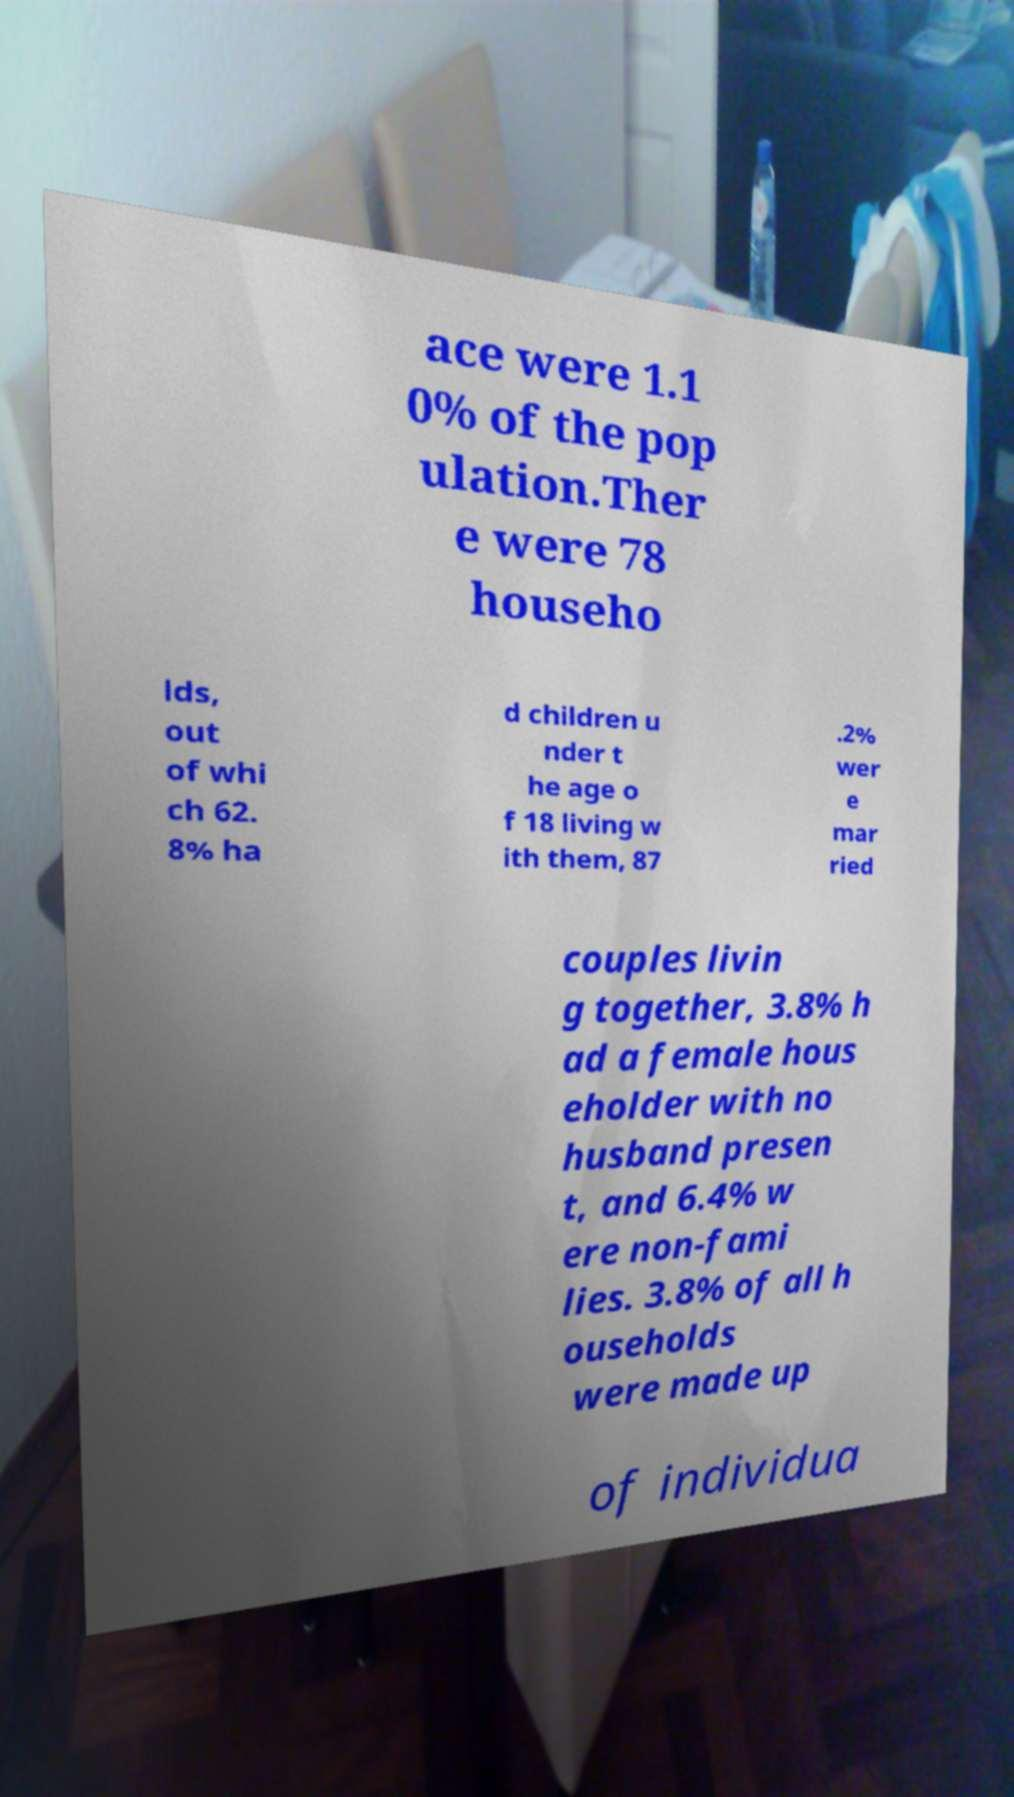Please read and relay the text visible in this image. What does it say? ace were 1.1 0% of the pop ulation.Ther e were 78 househo lds, out of whi ch 62. 8% ha d children u nder t he age o f 18 living w ith them, 87 .2% wer e mar ried couples livin g together, 3.8% h ad a female hous eholder with no husband presen t, and 6.4% w ere non-fami lies. 3.8% of all h ouseholds were made up of individua 